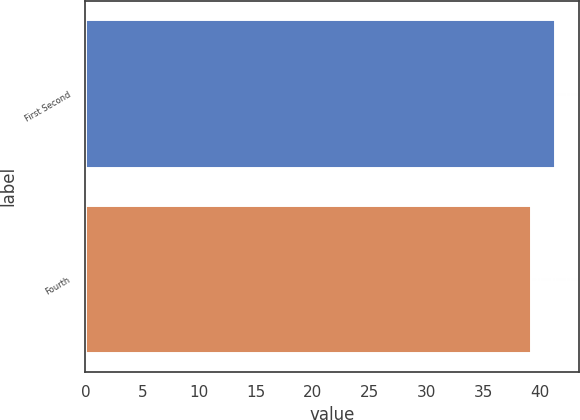Convert chart to OTSL. <chart><loc_0><loc_0><loc_500><loc_500><bar_chart><fcel>First Second<fcel>Fourth<nl><fcel>41.34<fcel>39.23<nl></chart> 